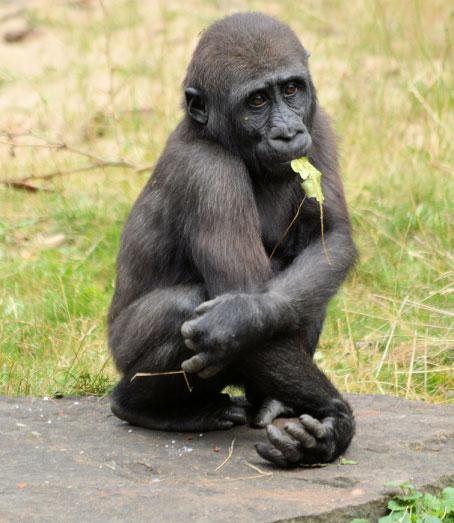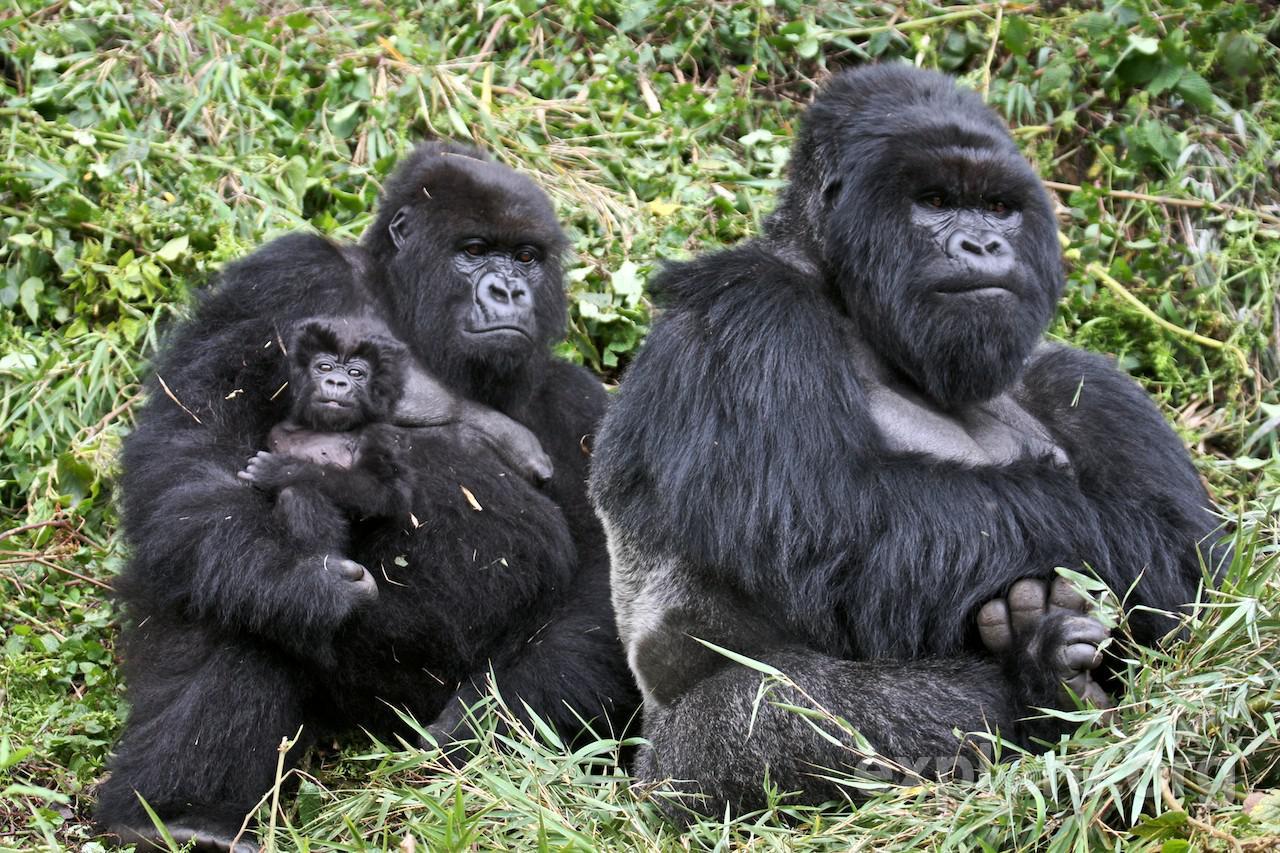The first image is the image on the left, the second image is the image on the right. Assess this claim about the two images: "Multiple gorillas can be seen in the right image.". Correct or not? Answer yes or no. Yes. The first image is the image on the left, the second image is the image on the right. Given the left and right images, does the statement "An image includes a baby gorilla held in the arms of an adult gorilla." hold true? Answer yes or no. Yes. 